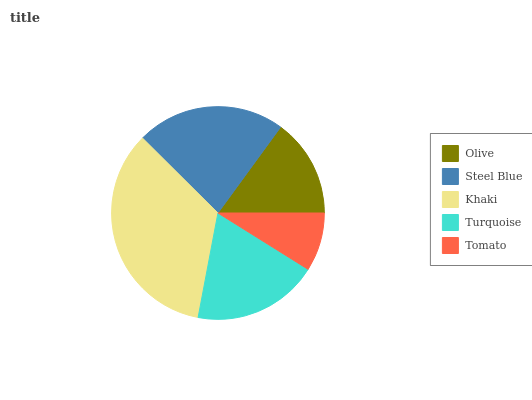Is Tomato the minimum?
Answer yes or no. Yes. Is Khaki the maximum?
Answer yes or no. Yes. Is Steel Blue the minimum?
Answer yes or no. No. Is Steel Blue the maximum?
Answer yes or no. No. Is Steel Blue greater than Olive?
Answer yes or no. Yes. Is Olive less than Steel Blue?
Answer yes or no. Yes. Is Olive greater than Steel Blue?
Answer yes or no. No. Is Steel Blue less than Olive?
Answer yes or no. No. Is Turquoise the high median?
Answer yes or no. Yes. Is Turquoise the low median?
Answer yes or no. Yes. Is Steel Blue the high median?
Answer yes or no. No. Is Khaki the low median?
Answer yes or no. No. 